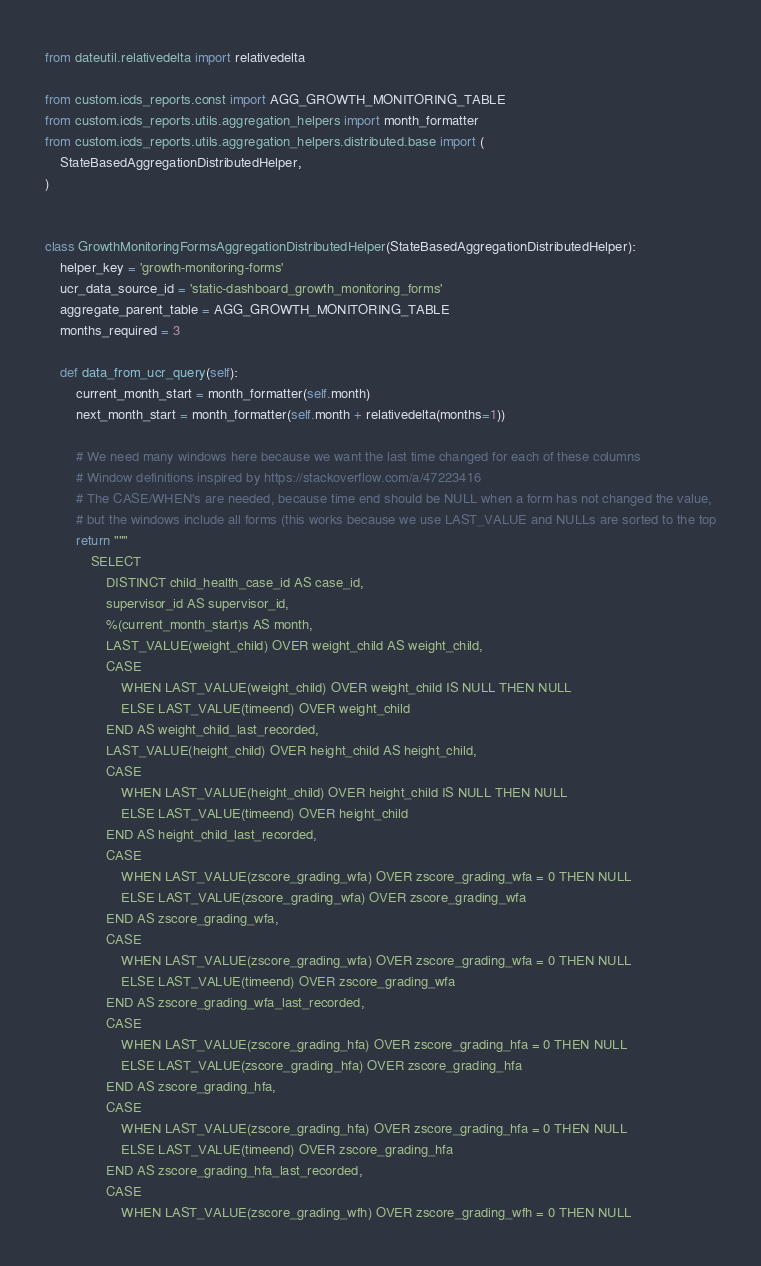Convert code to text. <code><loc_0><loc_0><loc_500><loc_500><_Python_>from dateutil.relativedelta import relativedelta

from custom.icds_reports.const import AGG_GROWTH_MONITORING_TABLE
from custom.icds_reports.utils.aggregation_helpers import month_formatter
from custom.icds_reports.utils.aggregation_helpers.distributed.base import (
    StateBasedAggregationDistributedHelper,
)


class GrowthMonitoringFormsAggregationDistributedHelper(StateBasedAggregationDistributedHelper):
    helper_key = 'growth-monitoring-forms'
    ucr_data_source_id = 'static-dashboard_growth_monitoring_forms'
    aggregate_parent_table = AGG_GROWTH_MONITORING_TABLE
    months_required = 3

    def data_from_ucr_query(self):
        current_month_start = month_formatter(self.month)
        next_month_start = month_formatter(self.month + relativedelta(months=1))

        # We need many windows here because we want the last time changed for each of these columns
        # Window definitions inspired by https://stackoverflow.com/a/47223416
        # The CASE/WHEN's are needed, because time end should be NULL when a form has not changed the value,
        # but the windows include all forms (this works because we use LAST_VALUE and NULLs are sorted to the top
        return """
            SELECT
                DISTINCT child_health_case_id AS case_id,
                supervisor_id AS supervisor_id,
                %(current_month_start)s AS month,
                LAST_VALUE(weight_child) OVER weight_child AS weight_child,
                CASE
                    WHEN LAST_VALUE(weight_child) OVER weight_child IS NULL THEN NULL
                    ELSE LAST_VALUE(timeend) OVER weight_child
                END AS weight_child_last_recorded,
                LAST_VALUE(height_child) OVER height_child AS height_child,
                CASE
                    WHEN LAST_VALUE(height_child) OVER height_child IS NULL THEN NULL
                    ELSE LAST_VALUE(timeend) OVER height_child
                END AS height_child_last_recorded,
                CASE
                    WHEN LAST_VALUE(zscore_grading_wfa) OVER zscore_grading_wfa = 0 THEN NULL
                    ELSE LAST_VALUE(zscore_grading_wfa) OVER zscore_grading_wfa
                END AS zscore_grading_wfa,
                CASE
                    WHEN LAST_VALUE(zscore_grading_wfa) OVER zscore_grading_wfa = 0 THEN NULL
                    ELSE LAST_VALUE(timeend) OVER zscore_grading_wfa
                END AS zscore_grading_wfa_last_recorded,
                CASE
                    WHEN LAST_VALUE(zscore_grading_hfa) OVER zscore_grading_hfa = 0 THEN NULL
                    ELSE LAST_VALUE(zscore_grading_hfa) OVER zscore_grading_hfa
                END AS zscore_grading_hfa,
                CASE
                    WHEN LAST_VALUE(zscore_grading_hfa) OVER zscore_grading_hfa = 0 THEN NULL
                    ELSE LAST_VALUE(timeend) OVER zscore_grading_hfa
                END AS zscore_grading_hfa_last_recorded,
                CASE
                    WHEN LAST_VALUE(zscore_grading_wfh) OVER zscore_grading_wfh = 0 THEN NULL</code> 